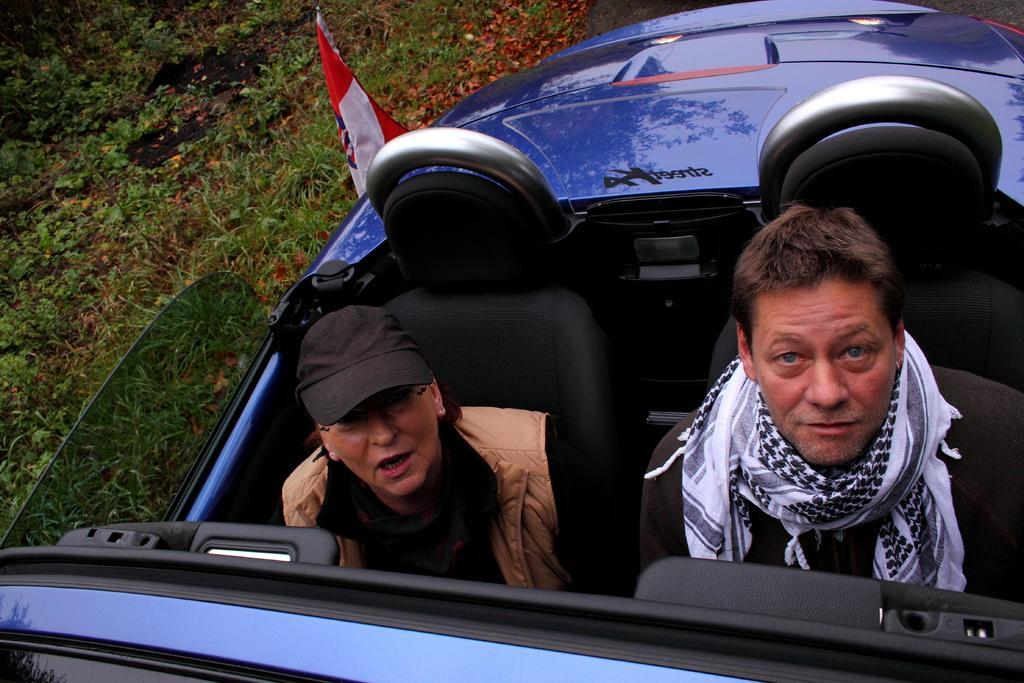Can you describe this image briefly? There is a women wearing a cap and jerking and a man with muffler sitting on a car. This car is of blue color. At background I can see a flag. I think this is attached to the car. And I can see grass and small plants at the left corner of the image. 